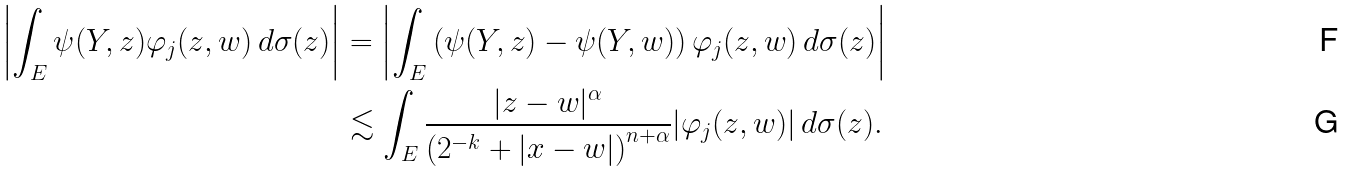Convert formula to latex. <formula><loc_0><loc_0><loc_500><loc_500>\left | \int _ { E } \psi ( Y , z ) \varphi _ { j } ( z , w ) \, d \sigma ( z ) \right | & = \left | \int _ { E } \left ( \psi ( Y , z ) - \psi ( Y , w ) \right ) \varphi _ { j } ( z , w ) \, d \sigma ( z ) \right | \\ & \lesssim \int _ { E } \frac { | z - w | ^ { \alpha } } { \left ( 2 ^ { - k } + | x - w | \right ) ^ { n + \alpha } } | \varphi _ { j } ( z , w ) | \, d \sigma ( z ) .</formula> 